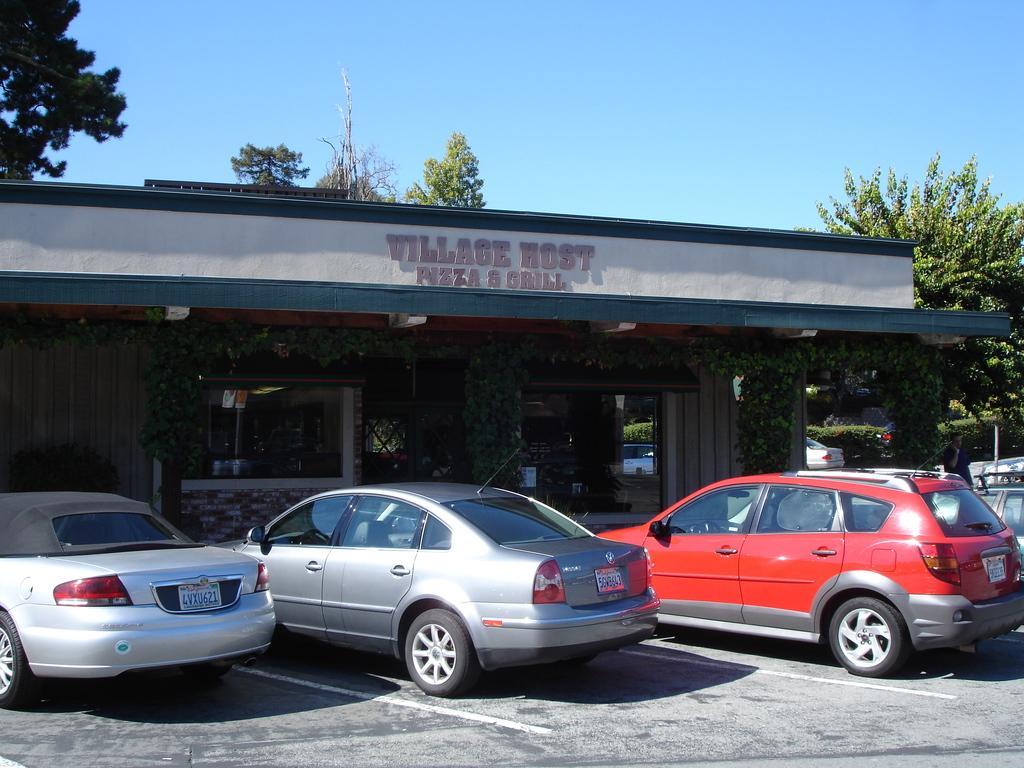Can you describe this image briefly? In this image we can see there are cars parked in front of the building and there are creeper plants to the wall. And there are trees, plants and the sky. 